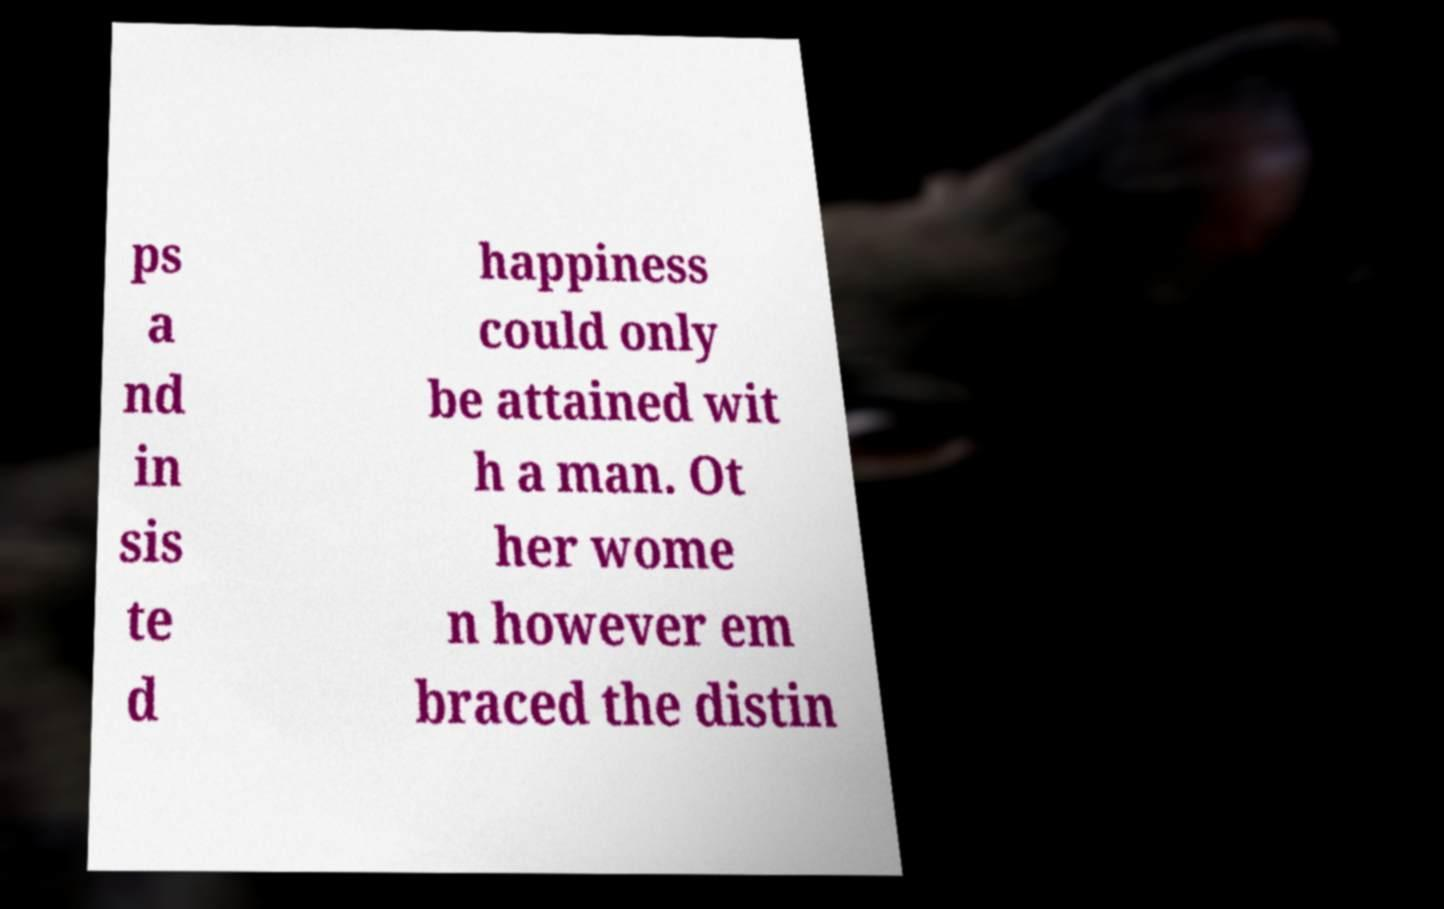I need the written content from this picture converted into text. Can you do that? ps a nd in sis te d happiness could only be attained wit h a man. Ot her wome n however em braced the distin 